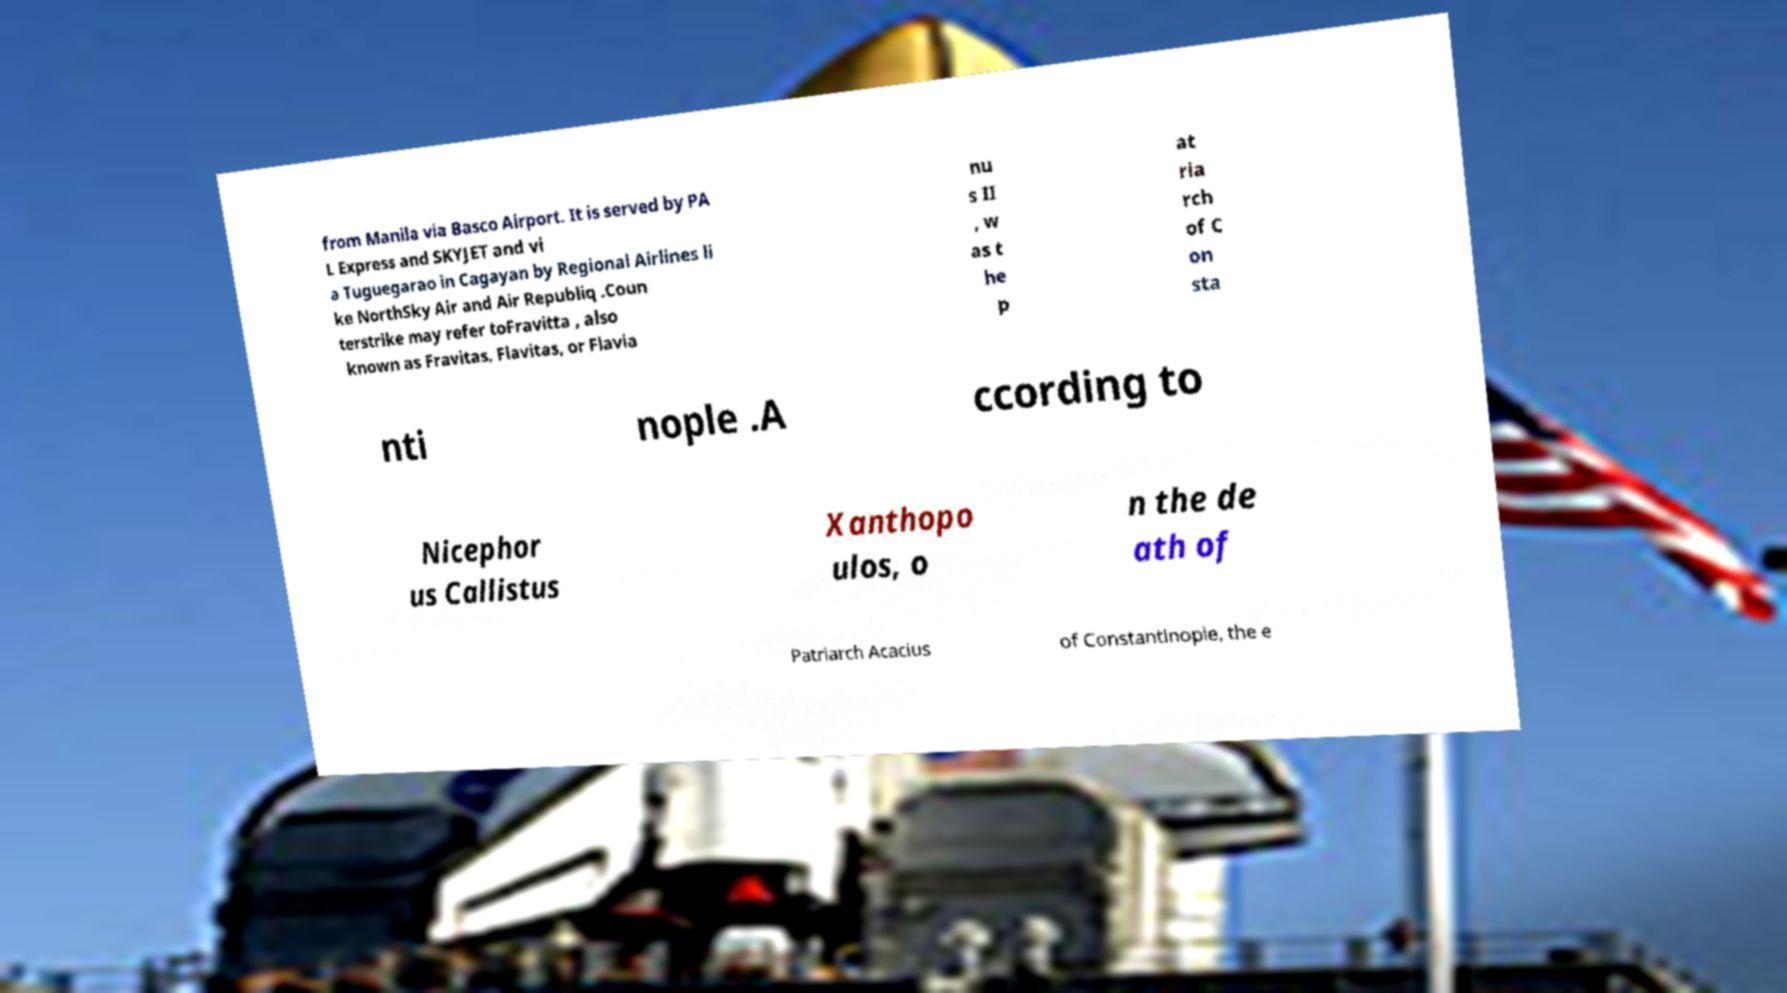Could you assist in decoding the text presented in this image and type it out clearly? from Manila via Basco Airport. It is served by PA L Express and SKYJET and vi a Tuguegarao in Cagayan by Regional Airlines li ke NorthSky Air and Air Republiq .Coun terstrike may refer toFravitta , also known as Fravitas, Flavitas, or Flavia nu s II , w as t he p at ria rch of C on sta nti nople .A ccording to Nicephor us Callistus Xanthopo ulos, o n the de ath of Patriarch Acacius of Constantinople, the e 